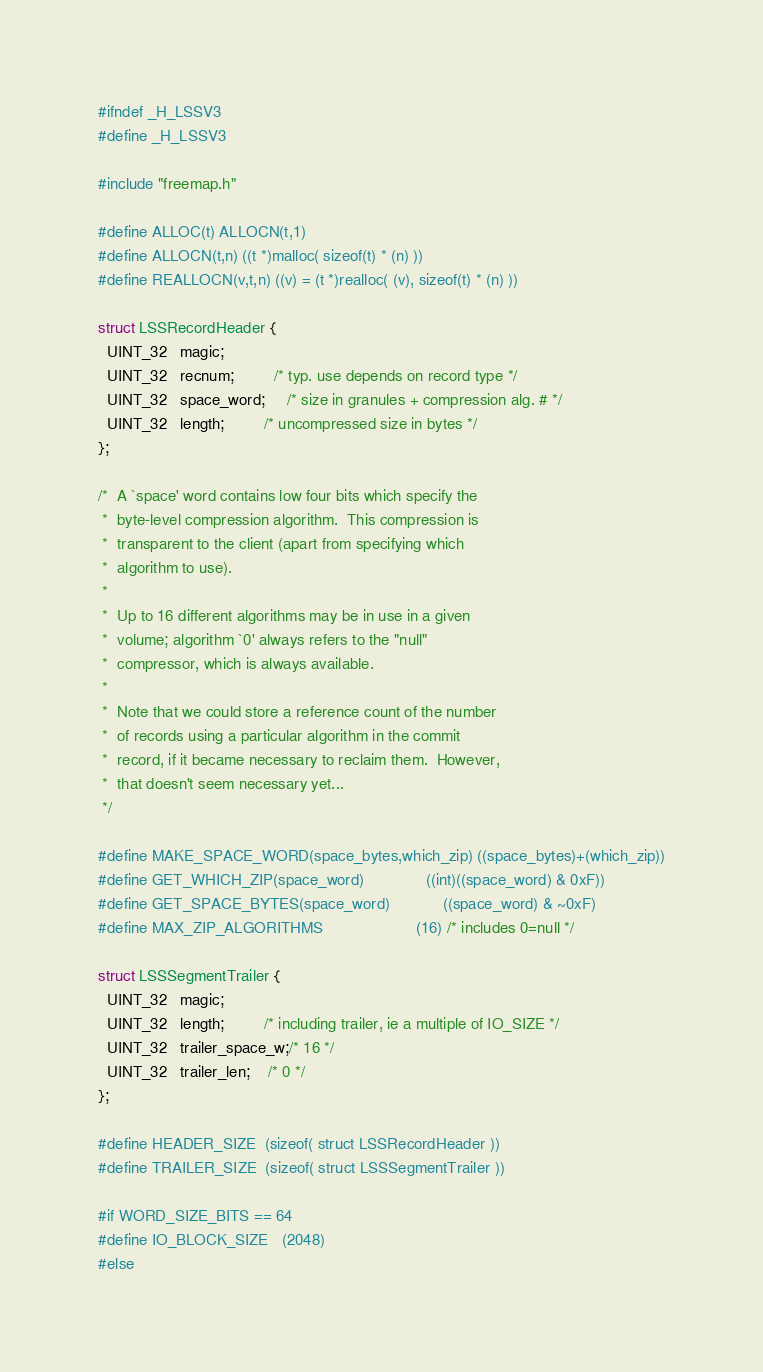<code> <loc_0><loc_0><loc_500><loc_500><_C_>#ifndef _H_LSSV3
#define _H_LSSV3

#include "freemap.h"

#define ALLOC(t) ALLOCN(t,1)
#define ALLOCN(t,n) ((t *)malloc( sizeof(t) * (n) ))
#define REALLOCN(v,t,n) ((v) = (t *)realloc( (v), sizeof(t) * (n) ))

struct LSSRecordHeader {
  UINT_32   magic;
  UINT_32   recnum;         /* typ. use depends on record type */
  UINT_32   space_word;     /* size in granules + compression alg. # */
  UINT_32   length;         /* uncompressed size in bytes */
};

/*  A `space' word contains low four bits which specify the
 *  byte-level compression algorithm.  This compression is
 *  transparent to the client (apart from specifying which
 *  algorithm to use).
 *
 *  Up to 16 different algorithms may be in use in a given
 *  volume; algorithm `0' always refers to the "null"
 *  compressor, which is always available.
 *
 *  Note that we could store a reference count of the number
 *  of records using a particular algorithm in the commit
 *  record, if it became necessary to reclaim them.  However,
 *  that doesn't seem necessary yet...
 */

#define MAKE_SPACE_WORD(space_bytes,which_zip) ((space_bytes)+(which_zip))
#define GET_WHICH_ZIP(space_word)              ((int)((space_word) & 0xF))
#define GET_SPACE_BYTES(space_word)            ((space_word) & ~0xF)
#define MAX_ZIP_ALGORITHMS                     (16) /* includes 0=null */

struct LSSSegmentTrailer {
  UINT_32   magic;
  UINT_32   length;         /* including trailer, ie a multiple of IO_SIZE */
  UINT_32   trailer_space_w;/* 16 */
  UINT_32   trailer_len;    /* 0 */
};

#define HEADER_SIZE  (sizeof( struct LSSRecordHeader ))
#define TRAILER_SIZE  (sizeof( struct LSSSegmentTrailer ))

#if WORD_SIZE_BITS == 64
#define IO_BLOCK_SIZE   (2048)
#else</code> 